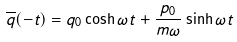<formula> <loc_0><loc_0><loc_500><loc_500>\overline { q } ( - t ) = q _ { 0 } \cosh \omega t + { \frac { p _ { 0 } } { m \omega } } \sinh \omega t</formula> 